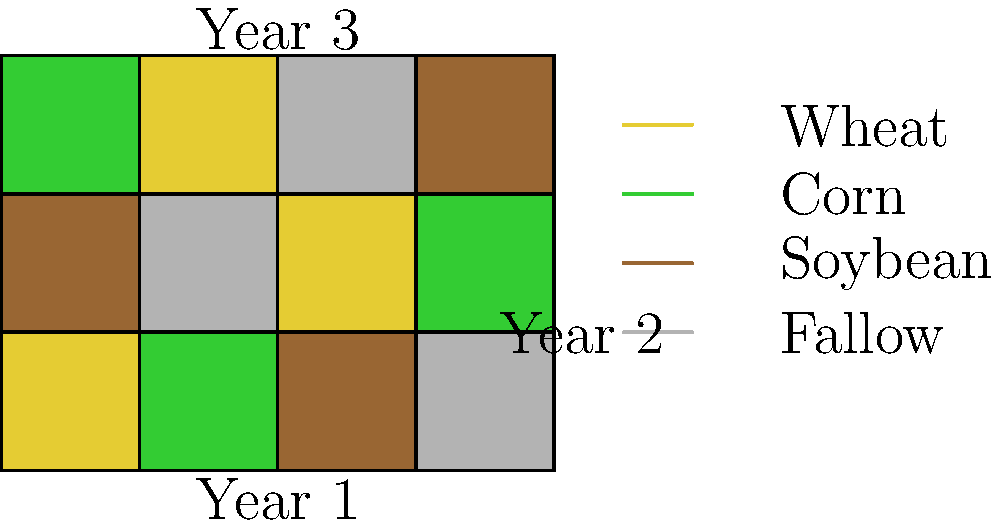Based on the aerial imagery of fields shown above, which crop rotation pattern is being implemented, and what is the primary benefit of this practice for soil health? To answer this question, let's analyze the image step-by-step:

1. The image shows a 4x3 grid representing 4 fields over 3 years.
2. Each color represents a different crop or field state:
   - Yellow: Wheat
   - Green: Corn
   - Brown: Soybean
   - Gray: Fallow (resting)

3. Observing the pattern for each field across the years:
   Field 1: Wheat → Soybean → Corn
   Field 2: Corn → Fallow → Wheat
   Field 3: Soybean → Wheat → Fallow
   Field 4: Fallow → Corn → Soybean

4. This pattern shows a 4-year rotation cycle: Wheat → Soybean → Corn → Fallow

5. The primary benefit of this crop rotation for soil health is:
   - Nutrient management: Different crops have different nutrient requirements and root depths. Rotation helps balance nutrient depletion and replenishment.
   - Pest and disease control: Alternating crops breaks pest and disease cycles.
   - Soil structure improvement: Varied root systems improve soil structure and organic matter content.
   - Nitrogen fixation: Legumes (like soybeans) fix nitrogen in the soil.
   - Weed suppression: Different crops compete with different weeds.
   - Fallow period: Allows soil to rest and recover.

The most significant benefit among these is the balanced nutrient management and soil structure improvement.
Answer: 4-year rotation (Wheat-Soybean-Corn-Fallow); balanced nutrient management and soil structure improvement 